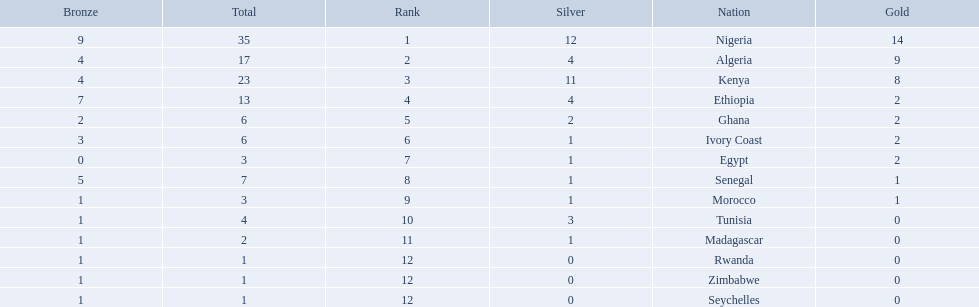What nations competed at the 1989 african championships in athletics? Nigeria, Algeria, Kenya, Ethiopia, Ghana, Ivory Coast, Egypt, Senegal, Morocco, Tunisia, Madagascar, Rwanda, Zimbabwe, Seychelles. What nations earned bronze medals? Nigeria, Algeria, Kenya, Ethiopia, Ghana, Ivory Coast, Senegal, Morocco, Tunisia, Madagascar, Rwanda, Zimbabwe, Seychelles. What nation did not earn a bronze medal? Egypt. Which nations competed in the 1989 african championships in athletics? Nigeria, Algeria, Kenya, Ethiopia, Ghana, Ivory Coast, Egypt, Senegal, Morocco, Tunisia, Madagascar, Rwanda, Zimbabwe, Seychelles. Of these nations, which earned 0 bronze medals? Egypt. 